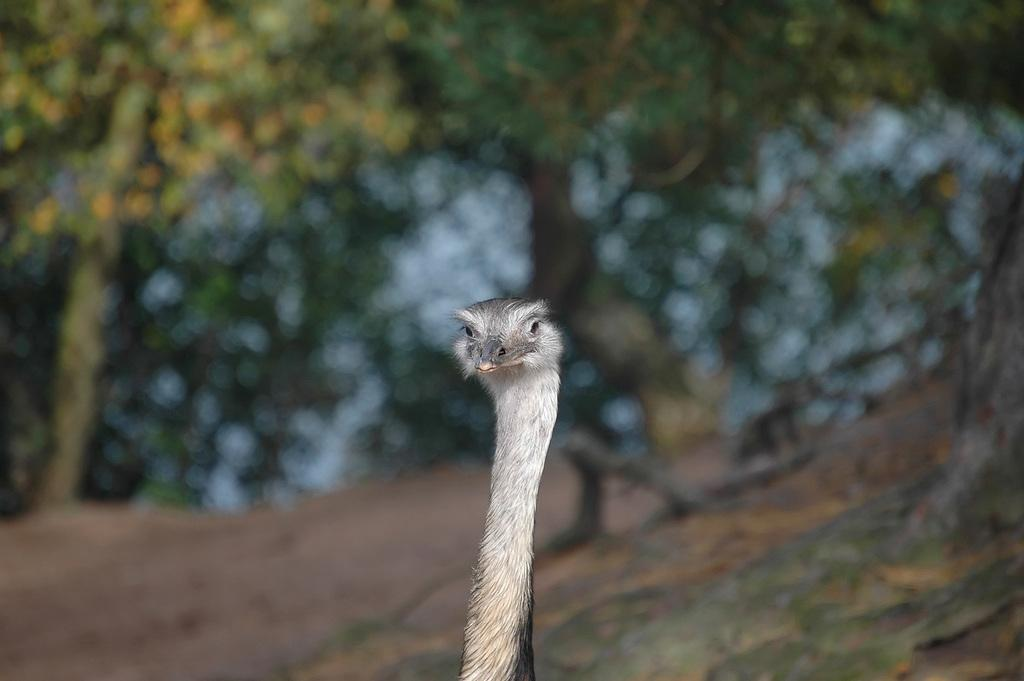What animal is the main subject of the image? There is an ostrich in the image. What can be seen in the distance behind the ostrich? There are trees in the background of the image. How would you describe the appearance of the background? The background is blurred. What type of veil is draped over the ostrich in the image? There is no veil present in the image; it features an ostrich and trees in the background. How many thumbs can be seen on the ostrich in the image? Ostriches do not have thumbs, so none can be seen in the image. 